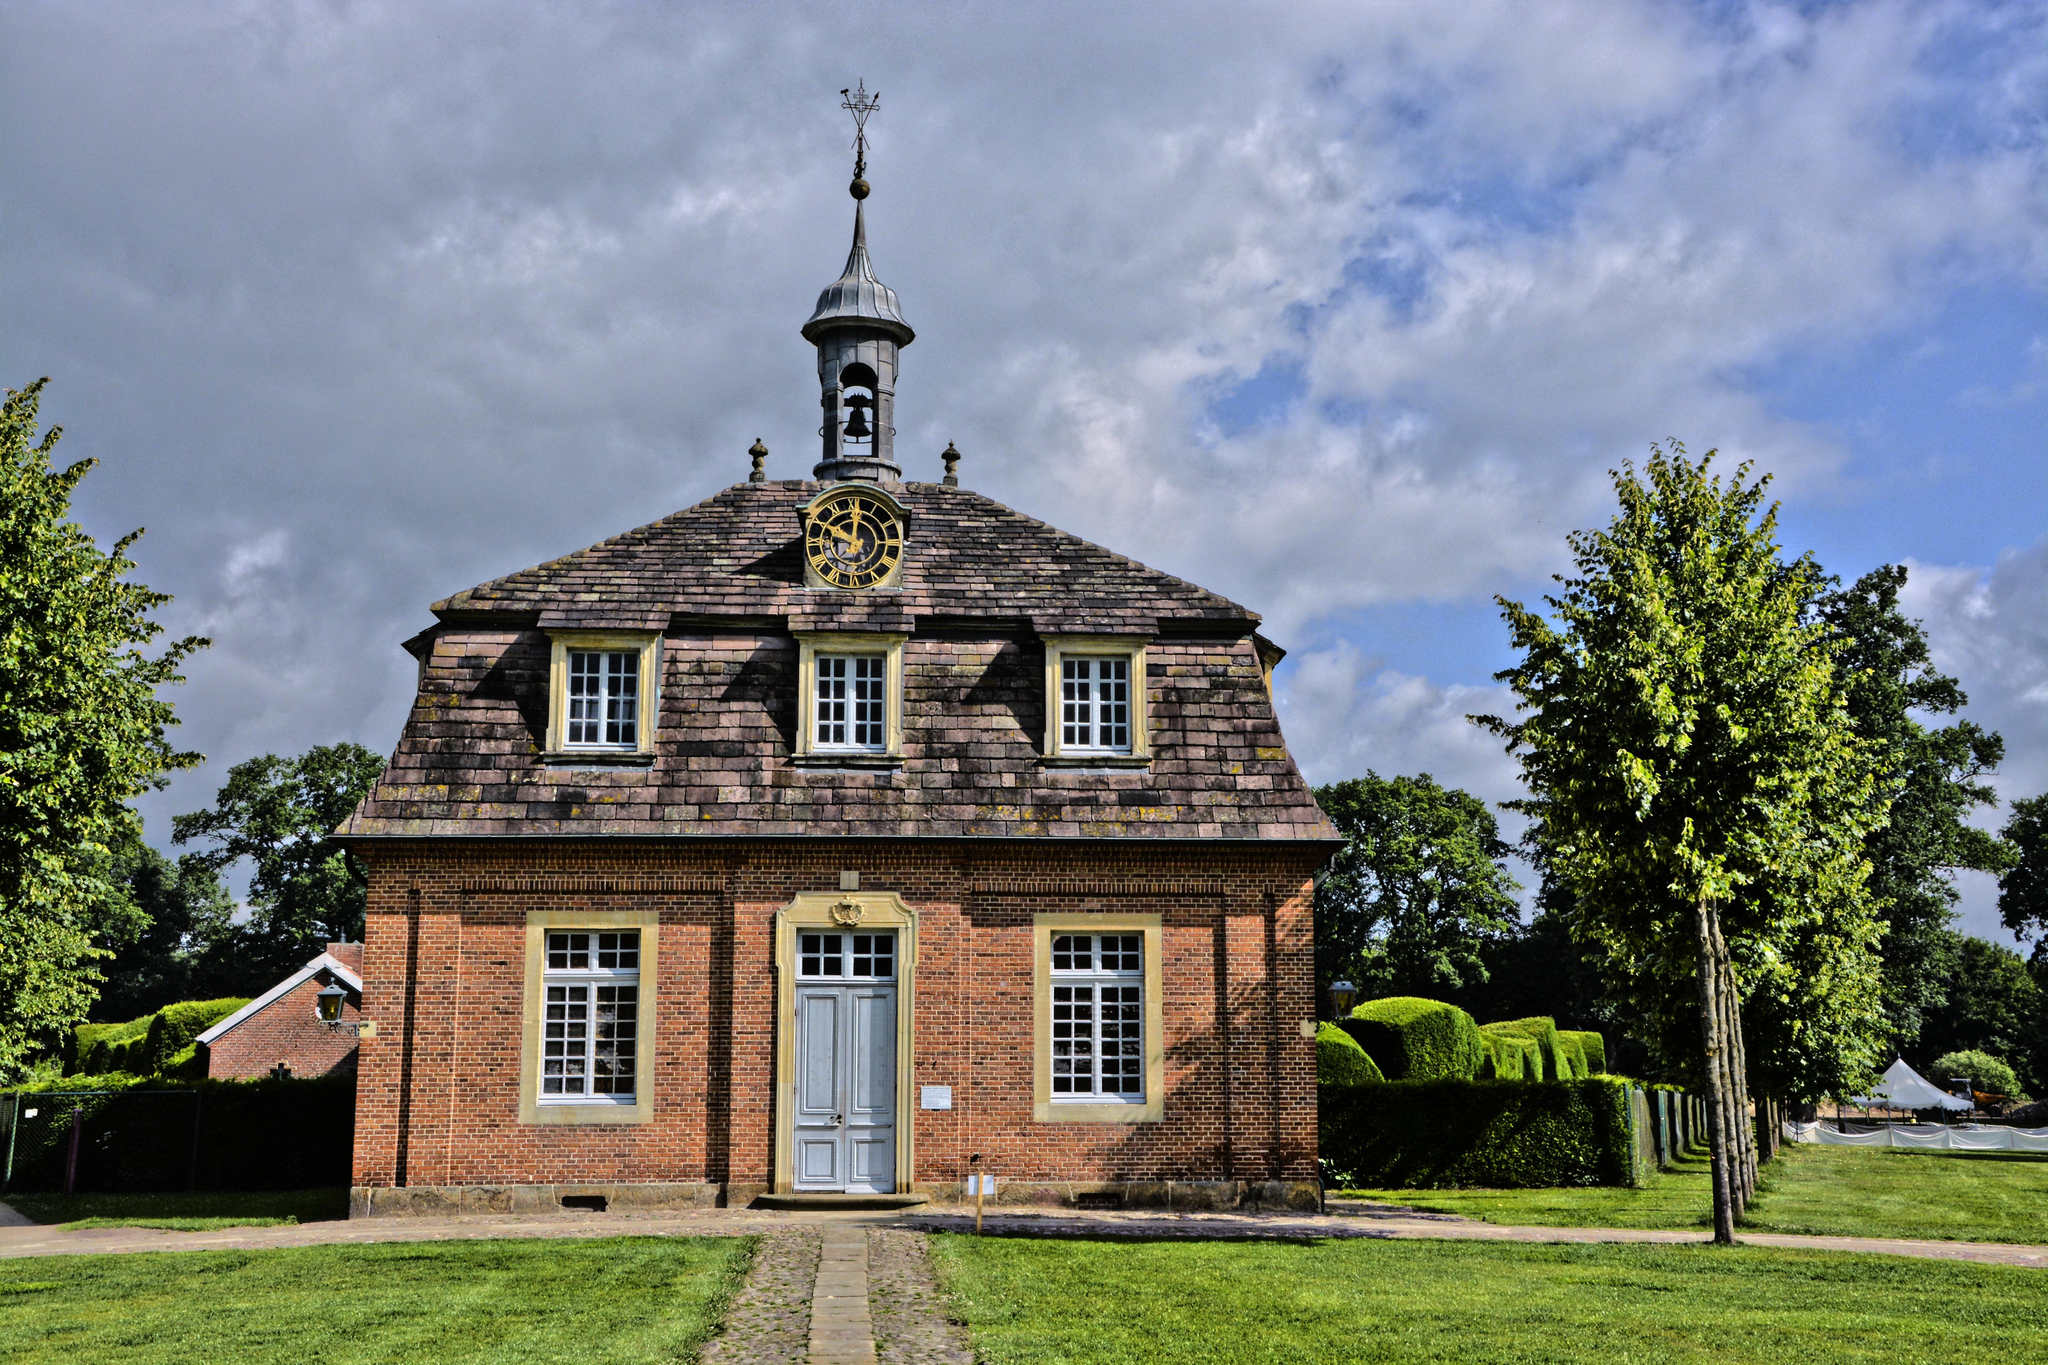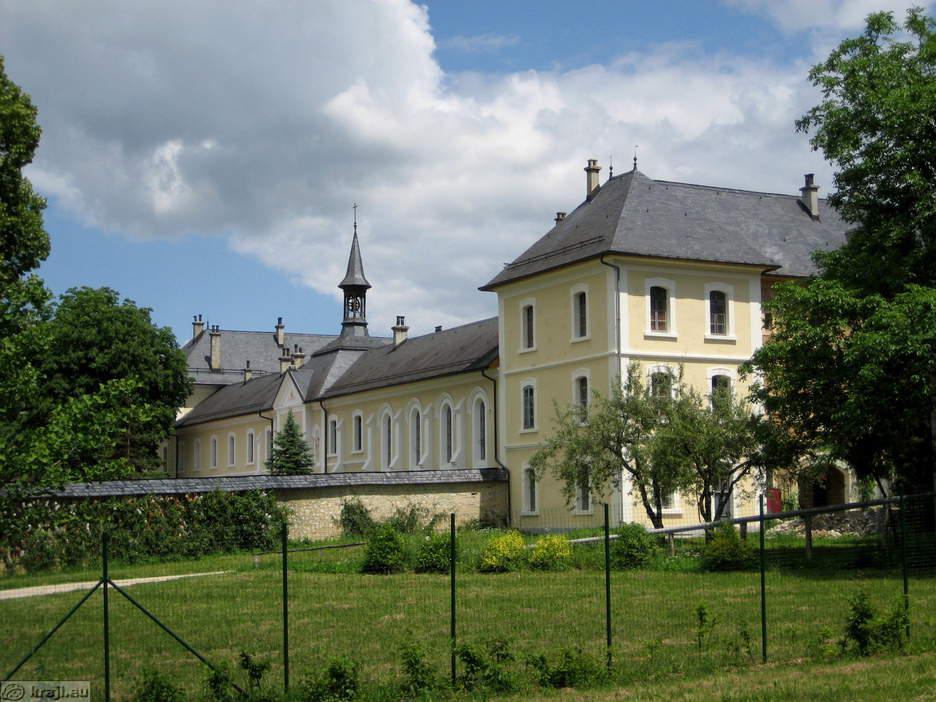The first image is the image on the left, the second image is the image on the right. For the images shown, is this caption "The building in the right image is yellow with a dark roof." true? Answer yes or no. Yes. 